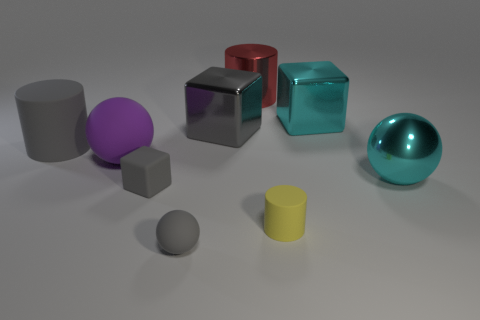Subtract all cylinders. How many objects are left? 6 Subtract 0 purple blocks. How many objects are left? 9 Subtract all purple metallic cylinders. Subtract all big rubber spheres. How many objects are left? 8 Add 6 purple matte balls. How many purple matte balls are left? 7 Add 3 shiny blocks. How many shiny blocks exist? 5 